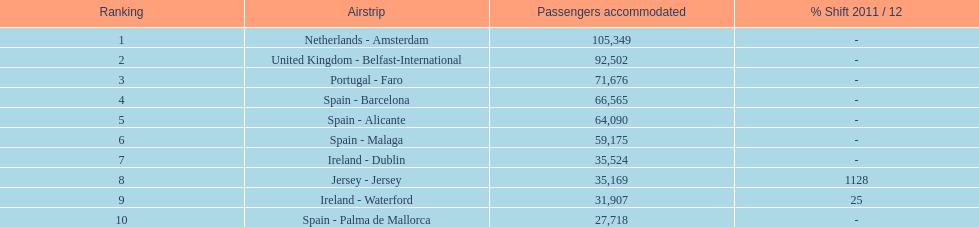How many airports in spain are among the 10 busiest routes to and from london southend airport in 2012? 4. 